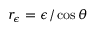<formula> <loc_0><loc_0><loc_500><loc_500>r _ { \epsilon } = \epsilon / \cos { \theta }</formula> 